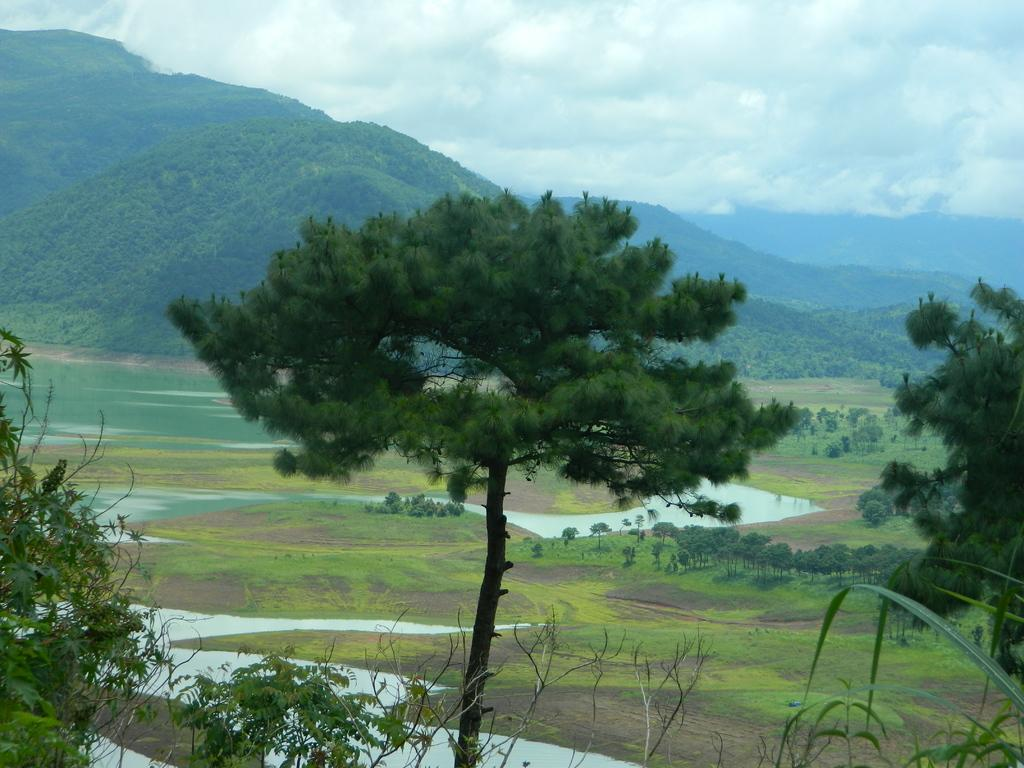What type of vegetation can be seen in the image? There are trees in the image. What geographical feature is visible in the background? There are mountains in the image. What natural element is present in the image? There is water visible in the image. What type of ground cover is present in the image? There is grass in the image. What part of the natural environment is visible in the image? The sky is visible in the image. What type of veil can be seen covering the mountains in the image? There is no veil present in the image; the mountains are visible in the background. What type of hate can be seen expressed by the trees in the image? There is no hate expressed by the trees or any other objects in the image. 